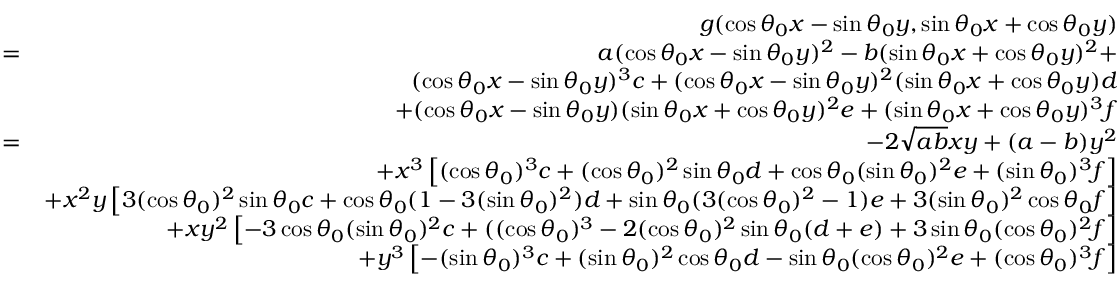<formula> <loc_0><loc_0><loc_500><loc_500>\begin{array} { r l r } & { g ( \cos \theta _ { 0 } x - \sin \theta _ { 0 } y , \sin \theta _ { 0 } x + \cos \theta _ { 0 } y ) } \\ & { = } & { a ( \cos \theta _ { 0 } x - \sin \theta _ { 0 } y ) ^ { 2 } - b ( \sin \theta _ { 0 } x + \cos \theta _ { 0 } y ) ^ { 2 } + } \\ & { ( \cos \theta _ { 0 } x - \sin \theta _ { 0 } y ) ^ { 3 } c + ( \cos \theta _ { 0 } x - \sin \theta _ { 0 } y ) ^ { 2 } ( \sin \theta _ { 0 } x + \cos \theta _ { 0 } y ) d } \\ & { + ( \cos \theta _ { 0 } x - \sin \theta _ { 0 } y ) ( \sin \theta _ { 0 } x + \cos \theta _ { 0 } y ) ^ { 2 } e + ( \sin \theta _ { 0 } x + \cos \theta _ { 0 } y ) ^ { 3 } f } \\ & { = } & { - 2 \sqrt { a b } x y + ( a - b ) y ^ { 2 } } \\ & { + x ^ { 3 } \left [ ( \cos \theta _ { 0 } ) ^ { 3 } c + ( \cos \theta _ { 0 } ) ^ { 2 } \sin \theta _ { 0 } d + \cos \theta _ { 0 } ( \sin \theta _ { 0 } ) ^ { 2 } e + ( \sin \theta _ { 0 } ) ^ { 3 } f \right ] } \\ & { + x ^ { 2 } y \left [ 3 ( \cos \theta _ { 0 } ) ^ { 2 } \sin \theta _ { 0 } c + \cos \theta _ { 0 } ( 1 - 3 ( \sin \theta _ { 0 } ) ^ { 2 } ) d + \sin \theta _ { 0 } ( 3 ( \cos \theta _ { 0 } ) ^ { 2 } - 1 ) e + 3 ( \sin \theta _ { 0 } ) ^ { 2 } \cos \theta _ { 0 } f \right ] } \\ & { + x y ^ { 2 } \left [ - 3 \cos \theta _ { 0 } ( \sin \theta _ { 0 } ) ^ { 2 } c + ( ( \cos \theta _ { 0 } ) ^ { 3 } - 2 ( \cos \theta _ { 0 } ) ^ { 2 } \sin \theta _ { 0 } ( d + e ) + 3 \sin \theta _ { 0 } ( \cos \theta _ { 0 } ) ^ { 2 } f \right ] } \\ & { + y ^ { 3 } \left [ - ( \sin \theta _ { 0 } ) ^ { 3 } c + ( \sin \theta _ { 0 } ) ^ { 2 } \cos \theta _ { 0 } d - \sin \theta _ { 0 } ( \cos \theta _ { 0 } ) ^ { 2 } e + ( \cos \theta _ { 0 } ) ^ { 3 } f \right ] } \end{array}</formula> 